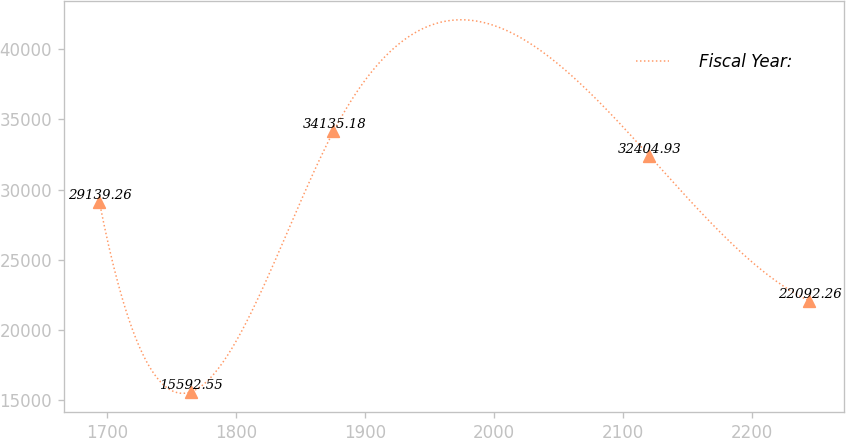<chart> <loc_0><loc_0><loc_500><loc_500><line_chart><ecel><fcel>Fiscal Year:<nl><fcel>1693.92<fcel>29139.3<nl><fcel>1764.73<fcel>15592.5<nl><fcel>1875.48<fcel>34135.2<nl><fcel>2120.38<fcel>32404.9<nl><fcel>2244.19<fcel>22092.3<nl></chart> 